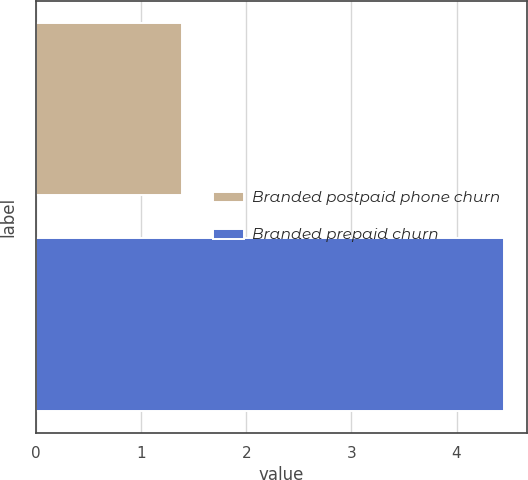Convert chart. <chart><loc_0><loc_0><loc_500><loc_500><bar_chart><fcel>Branded postpaid phone churn<fcel>Branded prepaid churn<nl><fcel>1.39<fcel>4.45<nl></chart> 